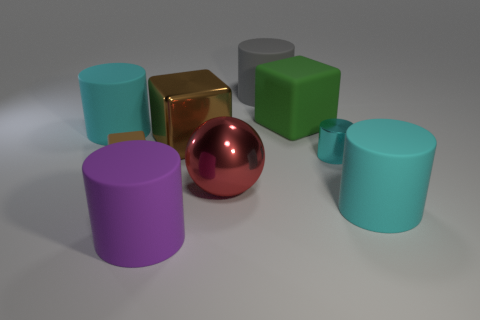How many objects are in the image, and can you describe their colors and shapes? In the image, there are seven objects in total, featuring a variety of shapes and colors. Starting from the left, there's a purple cylinder, a cyan cube, a gold cube, a green cube, a red sphere, a tiny green cylinder, and a slightly larger cyan cylinder. 